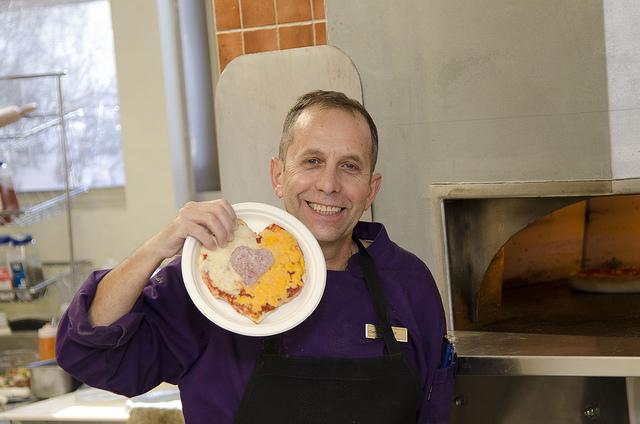What food is the heart shaped object made of? Please explain your reasoning. pizza. It is cooked dough with sauce and cheese 